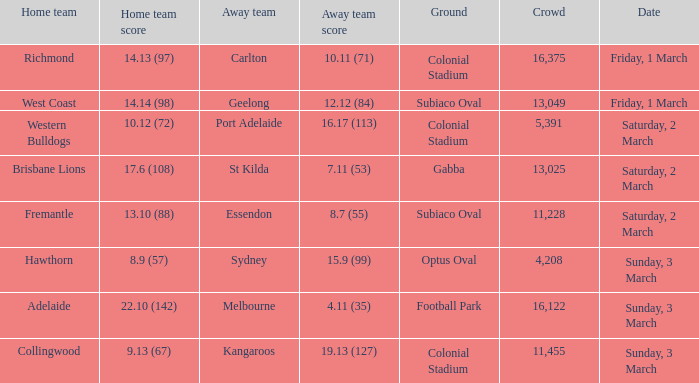Who is the away team when the home team scored 17.6 (108)? St Kilda. 